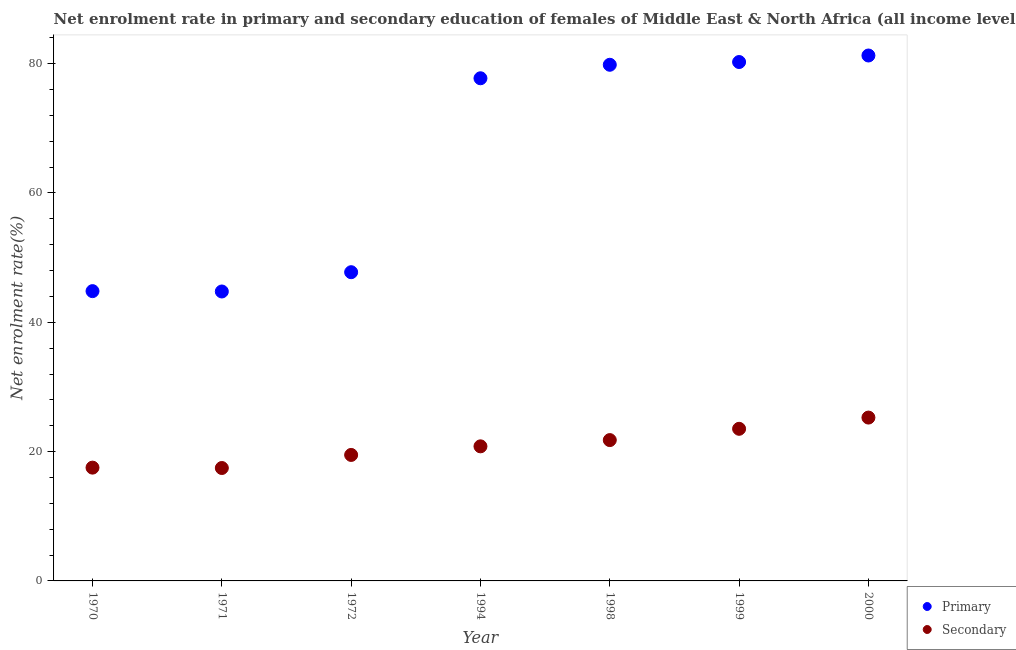How many different coloured dotlines are there?
Provide a short and direct response. 2. Is the number of dotlines equal to the number of legend labels?
Offer a very short reply. Yes. What is the enrollment rate in secondary education in 1970?
Your response must be concise. 17.52. Across all years, what is the maximum enrollment rate in primary education?
Provide a succinct answer. 81.26. Across all years, what is the minimum enrollment rate in secondary education?
Offer a very short reply. 17.46. In which year was the enrollment rate in primary education minimum?
Your answer should be very brief. 1971. What is the total enrollment rate in secondary education in the graph?
Ensure brevity in your answer.  145.85. What is the difference between the enrollment rate in secondary education in 1970 and that in 1971?
Your answer should be very brief. 0.06. What is the difference between the enrollment rate in secondary education in 1999 and the enrollment rate in primary education in 1970?
Give a very brief answer. -21.29. What is the average enrollment rate in primary education per year?
Your response must be concise. 65.2. In the year 1994, what is the difference between the enrollment rate in secondary education and enrollment rate in primary education?
Provide a succinct answer. -56.93. In how many years, is the enrollment rate in secondary education greater than 68 %?
Keep it short and to the point. 0. What is the ratio of the enrollment rate in secondary education in 1971 to that in 1998?
Your answer should be compact. 0.8. What is the difference between the highest and the second highest enrollment rate in secondary education?
Provide a succinct answer. 1.74. What is the difference between the highest and the lowest enrollment rate in secondary education?
Provide a succinct answer. 7.8. Is the sum of the enrollment rate in secondary education in 1994 and 2000 greater than the maximum enrollment rate in primary education across all years?
Keep it short and to the point. No. Does the enrollment rate in secondary education monotonically increase over the years?
Your response must be concise. No. Does the graph contain any zero values?
Provide a short and direct response. No. How are the legend labels stacked?
Your answer should be very brief. Vertical. What is the title of the graph?
Give a very brief answer. Net enrolment rate in primary and secondary education of females of Middle East & North Africa (all income levels). What is the label or title of the Y-axis?
Ensure brevity in your answer.  Net enrolment rate(%). What is the Net enrolment rate(%) of Primary in 1970?
Offer a terse response. 44.82. What is the Net enrolment rate(%) of Secondary in 1970?
Your answer should be compact. 17.52. What is the Net enrolment rate(%) in Primary in 1971?
Provide a short and direct response. 44.76. What is the Net enrolment rate(%) in Secondary in 1971?
Keep it short and to the point. 17.46. What is the Net enrolment rate(%) of Primary in 1972?
Give a very brief answer. 47.75. What is the Net enrolment rate(%) of Secondary in 1972?
Provide a short and direct response. 19.49. What is the Net enrolment rate(%) of Primary in 1994?
Ensure brevity in your answer.  77.74. What is the Net enrolment rate(%) of Secondary in 1994?
Keep it short and to the point. 20.81. What is the Net enrolment rate(%) of Primary in 1998?
Offer a terse response. 79.83. What is the Net enrolment rate(%) of Secondary in 1998?
Keep it short and to the point. 21.78. What is the Net enrolment rate(%) in Primary in 1999?
Your answer should be very brief. 80.25. What is the Net enrolment rate(%) in Secondary in 1999?
Your response must be concise. 23.53. What is the Net enrolment rate(%) in Primary in 2000?
Provide a short and direct response. 81.26. What is the Net enrolment rate(%) in Secondary in 2000?
Ensure brevity in your answer.  25.26. Across all years, what is the maximum Net enrolment rate(%) in Primary?
Your answer should be compact. 81.26. Across all years, what is the maximum Net enrolment rate(%) in Secondary?
Offer a terse response. 25.26. Across all years, what is the minimum Net enrolment rate(%) of Primary?
Make the answer very short. 44.76. Across all years, what is the minimum Net enrolment rate(%) of Secondary?
Ensure brevity in your answer.  17.46. What is the total Net enrolment rate(%) of Primary in the graph?
Keep it short and to the point. 456.41. What is the total Net enrolment rate(%) in Secondary in the graph?
Provide a succinct answer. 145.85. What is the difference between the Net enrolment rate(%) in Primary in 1970 and that in 1971?
Your answer should be compact. 0.05. What is the difference between the Net enrolment rate(%) of Secondary in 1970 and that in 1971?
Keep it short and to the point. 0.06. What is the difference between the Net enrolment rate(%) in Primary in 1970 and that in 1972?
Provide a short and direct response. -2.93. What is the difference between the Net enrolment rate(%) in Secondary in 1970 and that in 1972?
Give a very brief answer. -1.96. What is the difference between the Net enrolment rate(%) in Primary in 1970 and that in 1994?
Provide a succinct answer. -32.92. What is the difference between the Net enrolment rate(%) in Secondary in 1970 and that in 1994?
Your response must be concise. -3.29. What is the difference between the Net enrolment rate(%) in Primary in 1970 and that in 1998?
Provide a short and direct response. -35.01. What is the difference between the Net enrolment rate(%) in Secondary in 1970 and that in 1998?
Offer a very short reply. -4.26. What is the difference between the Net enrolment rate(%) of Primary in 1970 and that in 1999?
Offer a very short reply. -35.43. What is the difference between the Net enrolment rate(%) of Secondary in 1970 and that in 1999?
Your response must be concise. -6. What is the difference between the Net enrolment rate(%) in Primary in 1970 and that in 2000?
Provide a short and direct response. -36.44. What is the difference between the Net enrolment rate(%) of Secondary in 1970 and that in 2000?
Your answer should be compact. -7.74. What is the difference between the Net enrolment rate(%) in Primary in 1971 and that in 1972?
Your response must be concise. -2.98. What is the difference between the Net enrolment rate(%) in Secondary in 1971 and that in 1972?
Offer a terse response. -2.02. What is the difference between the Net enrolment rate(%) in Primary in 1971 and that in 1994?
Make the answer very short. -32.98. What is the difference between the Net enrolment rate(%) in Secondary in 1971 and that in 1994?
Your answer should be very brief. -3.35. What is the difference between the Net enrolment rate(%) of Primary in 1971 and that in 1998?
Your answer should be compact. -35.06. What is the difference between the Net enrolment rate(%) of Secondary in 1971 and that in 1998?
Keep it short and to the point. -4.32. What is the difference between the Net enrolment rate(%) in Primary in 1971 and that in 1999?
Make the answer very short. -35.49. What is the difference between the Net enrolment rate(%) of Secondary in 1971 and that in 1999?
Give a very brief answer. -6.06. What is the difference between the Net enrolment rate(%) of Primary in 1971 and that in 2000?
Keep it short and to the point. -36.5. What is the difference between the Net enrolment rate(%) of Secondary in 1971 and that in 2000?
Provide a succinct answer. -7.8. What is the difference between the Net enrolment rate(%) of Primary in 1972 and that in 1994?
Keep it short and to the point. -29.99. What is the difference between the Net enrolment rate(%) of Secondary in 1972 and that in 1994?
Give a very brief answer. -1.33. What is the difference between the Net enrolment rate(%) of Primary in 1972 and that in 1998?
Provide a short and direct response. -32.08. What is the difference between the Net enrolment rate(%) of Secondary in 1972 and that in 1998?
Provide a short and direct response. -2.3. What is the difference between the Net enrolment rate(%) in Primary in 1972 and that in 1999?
Give a very brief answer. -32.51. What is the difference between the Net enrolment rate(%) of Secondary in 1972 and that in 1999?
Your answer should be very brief. -4.04. What is the difference between the Net enrolment rate(%) in Primary in 1972 and that in 2000?
Provide a short and direct response. -33.51. What is the difference between the Net enrolment rate(%) of Secondary in 1972 and that in 2000?
Keep it short and to the point. -5.78. What is the difference between the Net enrolment rate(%) of Primary in 1994 and that in 1998?
Your answer should be very brief. -2.09. What is the difference between the Net enrolment rate(%) of Secondary in 1994 and that in 1998?
Give a very brief answer. -0.97. What is the difference between the Net enrolment rate(%) of Primary in 1994 and that in 1999?
Make the answer very short. -2.51. What is the difference between the Net enrolment rate(%) of Secondary in 1994 and that in 1999?
Keep it short and to the point. -2.71. What is the difference between the Net enrolment rate(%) of Primary in 1994 and that in 2000?
Your response must be concise. -3.52. What is the difference between the Net enrolment rate(%) in Secondary in 1994 and that in 2000?
Offer a very short reply. -4.45. What is the difference between the Net enrolment rate(%) in Primary in 1998 and that in 1999?
Offer a terse response. -0.42. What is the difference between the Net enrolment rate(%) of Secondary in 1998 and that in 1999?
Your answer should be compact. -1.75. What is the difference between the Net enrolment rate(%) in Primary in 1998 and that in 2000?
Keep it short and to the point. -1.43. What is the difference between the Net enrolment rate(%) of Secondary in 1998 and that in 2000?
Offer a very short reply. -3.48. What is the difference between the Net enrolment rate(%) of Primary in 1999 and that in 2000?
Your response must be concise. -1.01. What is the difference between the Net enrolment rate(%) of Secondary in 1999 and that in 2000?
Your response must be concise. -1.74. What is the difference between the Net enrolment rate(%) in Primary in 1970 and the Net enrolment rate(%) in Secondary in 1971?
Offer a terse response. 27.35. What is the difference between the Net enrolment rate(%) in Primary in 1970 and the Net enrolment rate(%) in Secondary in 1972?
Provide a short and direct response. 25.33. What is the difference between the Net enrolment rate(%) of Primary in 1970 and the Net enrolment rate(%) of Secondary in 1994?
Provide a short and direct response. 24. What is the difference between the Net enrolment rate(%) in Primary in 1970 and the Net enrolment rate(%) in Secondary in 1998?
Keep it short and to the point. 23.04. What is the difference between the Net enrolment rate(%) in Primary in 1970 and the Net enrolment rate(%) in Secondary in 1999?
Keep it short and to the point. 21.29. What is the difference between the Net enrolment rate(%) of Primary in 1970 and the Net enrolment rate(%) of Secondary in 2000?
Offer a terse response. 19.56. What is the difference between the Net enrolment rate(%) in Primary in 1971 and the Net enrolment rate(%) in Secondary in 1972?
Offer a terse response. 25.28. What is the difference between the Net enrolment rate(%) of Primary in 1971 and the Net enrolment rate(%) of Secondary in 1994?
Your answer should be very brief. 23.95. What is the difference between the Net enrolment rate(%) of Primary in 1971 and the Net enrolment rate(%) of Secondary in 1998?
Ensure brevity in your answer.  22.98. What is the difference between the Net enrolment rate(%) of Primary in 1971 and the Net enrolment rate(%) of Secondary in 1999?
Give a very brief answer. 21.24. What is the difference between the Net enrolment rate(%) in Primary in 1971 and the Net enrolment rate(%) in Secondary in 2000?
Offer a terse response. 19.5. What is the difference between the Net enrolment rate(%) in Primary in 1972 and the Net enrolment rate(%) in Secondary in 1994?
Give a very brief answer. 26.93. What is the difference between the Net enrolment rate(%) of Primary in 1972 and the Net enrolment rate(%) of Secondary in 1998?
Your answer should be compact. 25.97. What is the difference between the Net enrolment rate(%) of Primary in 1972 and the Net enrolment rate(%) of Secondary in 1999?
Keep it short and to the point. 24.22. What is the difference between the Net enrolment rate(%) in Primary in 1972 and the Net enrolment rate(%) in Secondary in 2000?
Provide a short and direct response. 22.48. What is the difference between the Net enrolment rate(%) of Primary in 1994 and the Net enrolment rate(%) of Secondary in 1998?
Offer a terse response. 55.96. What is the difference between the Net enrolment rate(%) in Primary in 1994 and the Net enrolment rate(%) in Secondary in 1999?
Ensure brevity in your answer.  54.21. What is the difference between the Net enrolment rate(%) of Primary in 1994 and the Net enrolment rate(%) of Secondary in 2000?
Keep it short and to the point. 52.48. What is the difference between the Net enrolment rate(%) in Primary in 1998 and the Net enrolment rate(%) in Secondary in 1999?
Offer a very short reply. 56.3. What is the difference between the Net enrolment rate(%) of Primary in 1998 and the Net enrolment rate(%) of Secondary in 2000?
Ensure brevity in your answer.  54.56. What is the difference between the Net enrolment rate(%) of Primary in 1999 and the Net enrolment rate(%) of Secondary in 2000?
Your response must be concise. 54.99. What is the average Net enrolment rate(%) in Primary per year?
Your response must be concise. 65.2. What is the average Net enrolment rate(%) in Secondary per year?
Provide a short and direct response. 20.84. In the year 1970, what is the difference between the Net enrolment rate(%) in Primary and Net enrolment rate(%) in Secondary?
Provide a short and direct response. 27.3. In the year 1971, what is the difference between the Net enrolment rate(%) of Primary and Net enrolment rate(%) of Secondary?
Offer a very short reply. 27.3. In the year 1972, what is the difference between the Net enrolment rate(%) in Primary and Net enrolment rate(%) in Secondary?
Provide a succinct answer. 28.26. In the year 1994, what is the difference between the Net enrolment rate(%) of Primary and Net enrolment rate(%) of Secondary?
Offer a very short reply. 56.93. In the year 1998, what is the difference between the Net enrolment rate(%) of Primary and Net enrolment rate(%) of Secondary?
Make the answer very short. 58.05. In the year 1999, what is the difference between the Net enrolment rate(%) in Primary and Net enrolment rate(%) in Secondary?
Offer a very short reply. 56.73. In the year 2000, what is the difference between the Net enrolment rate(%) in Primary and Net enrolment rate(%) in Secondary?
Offer a very short reply. 56. What is the ratio of the Net enrolment rate(%) in Primary in 1970 to that in 1971?
Your answer should be compact. 1. What is the ratio of the Net enrolment rate(%) in Primary in 1970 to that in 1972?
Offer a terse response. 0.94. What is the ratio of the Net enrolment rate(%) of Secondary in 1970 to that in 1972?
Your answer should be compact. 0.9. What is the ratio of the Net enrolment rate(%) in Primary in 1970 to that in 1994?
Your answer should be compact. 0.58. What is the ratio of the Net enrolment rate(%) in Secondary in 1970 to that in 1994?
Your answer should be compact. 0.84. What is the ratio of the Net enrolment rate(%) of Primary in 1970 to that in 1998?
Make the answer very short. 0.56. What is the ratio of the Net enrolment rate(%) of Secondary in 1970 to that in 1998?
Provide a short and direct response. 0.8. What is the ratio of the Net enrolment rate(%) of Primary in 1970 to that in 1999?
Ensure brevity in your answer.  0.56. What is the ratio of the Net enrolment rate(%) in Secondary in 1970 to that in 1999?
Your answer should be compact. 0.74. What is the ratio of the Net enrolment rate(%) of Primary in 1970 to that in 2000?
Give a very brief answer. 0.55. What is the ratio of the Net enrolment rate(%) of Secondary in 1970 to that in 2000?
Offer a terse response. 0.69. What is the ratio of the Net enrolment rate(%) in Secondary in 1971 to that in 1972?
Keep it short and to the point. 0.9. What is the ratio of the Net enrolment rate(%) in Primary in 1971 to that in 1994?
Offer a terse response. 0.58. What is the ratio of the Net enrolment rate(%) in Secondary in 1971 to that in 1994?
Offer a terse response. 0.84. What is the ratio of the Net enrolment rate(%) of Primary in 1971 to that in 1998?
Provide a succinct answer. 0.56. What is the ratio of the Net enrolment rate(%) in Secondary in 1971 to that in 1998?
Offer a terse response. 0.8. What is the ratio of the Net enrolment rate(%) of Primary in 1971 to that in 1999?
Provide a short and direct response. 0.56. What is the ratio of the Net enrolment rate(%) in Secondary in 1971 to that in 1999?
Keep it short and to the point. 0.74. What is the ratio of the Net enrolment rate(%) in Primary in 1971 to that in 2000?
Your answer should be compact. 0.55. What is the ratio of the Net enrolment rate(%) of Secondary in 1971 to that in 2000?
Provide a short and direct response. 0.69. What is the ratio of the Net enrolment rate(%) in Primary in 1972 to that in 1994?
Provide a succinct answer. 0.61. What is the ratio of the Net enrolment rate(%) in Secondary in 1972 to that in 1994?
Make the answer very short. 0.94. What is the ratio of the Net enrolment rate(%) of Primary in 1972 to that in 1998?
Your answer should be compact. 0.6. What is the ratio of the Net enrolment rate(%) of Secondary in 1972 to that in 1998?
Your answer should be very brief. 0.89. What is the ratio of the Net enrolment rate(%) of Primary in 1972 to that in 1999?
Give a very brief answer. 0.59. What is the ratio of the Net enrolment rate(%) of Secondary in 1972 to that in 1999?
Provide a succinct answer. 0.83. What is the ratio of the Net enrolment rate(%) in Primary in 1972 to that in 2000?
Ensure brevity in your answer.  0.59. What is the ratio of the Net enrolment rate(%) in Secondary in 1972 to that in 2000?
Make the answer very short. 0.77. What is the ratio of the Net enrolment rate(%) of Primary in 1994 to that in 1998?
Offer a very short reply. 0.97. What is the ratio of the Net enrolment rate(%) of Secondary in 1994 to that in 1998?
Offer a terse response. 0.96. What is the ratio of the Net enrolment rate(%) in Primary in 1994 to that in 1999?
Offer a terse response. 0.97. What is the ratio of the Net enrolment rate(%) of Secondary in 1994 to that in 1999?
Your answer should be compact. 0.88. What is the ratio of the Net enrolment rate(%) in Primary in 1994 to that in 2000?
Provide a succinct answer. 0.96. What is the ratio of the Net enrolment rate(%) of Secondary in 1994 to that in 2000?
Make the answer very short. 0.82. What is the ratio of the Net enrolment rate(%) in Secondary in 1998 to that in 1999?
Your answer should be very brief. 0.93. What is the ratio of the Net enrolment rate(%) in Primary in 1998 to that in 2000?
Give a very brief answer. 0.98. What is the ratio of the Net enrolment rate(%) in Secondary in 1998 to that in 2000?
Keep it short and to the point. 0.86. What is the ratio of the Net enrolment rate(%) in Primary in 1999 to that in 2000?
Offer a very short reply. 0.99. What is the ratio of the Net enrolment rate(%) in Secondary in 1999 to that in 2000?
Your answer should be very brief. 0.93. What is the difference between the highest and the second highest Net enrolment rate(%) in Primary?
Your answer should be compact. 1.01. What is the difference between the highest and the second highest Net enrolment rate(%) in Secondary?
Ensure brevity in your answer.  1.74. What is the difference between the highest and the lowest Net enrolment rate(%) in Primary?
Offer a very short reply. 36.5. What is the difference between the highest and the lowest Net enrolment rate(%) of Secondary?
Offer a terse response. 7.8. 